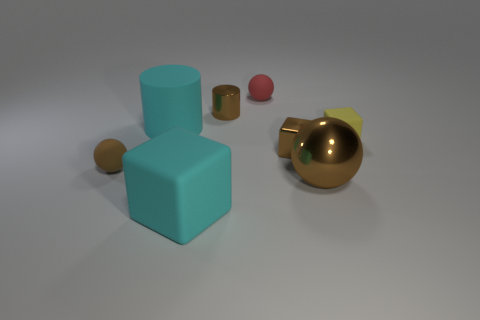Add 2 large blue metallic blocks. How many objects exist? 10 Subtract all cylinders. How many objects are left? 6 Add 8 big purple metal cylinders. How many big purple metal cylinders exist? 8 Subtract 0 green cylinders. How many objects are left? 8 Subtract all tiny brown spheres. Subtract all tiny purple matte balls. How many objects are left? 7 Add 7 small matte objects. How many small matte objects are left? 10 